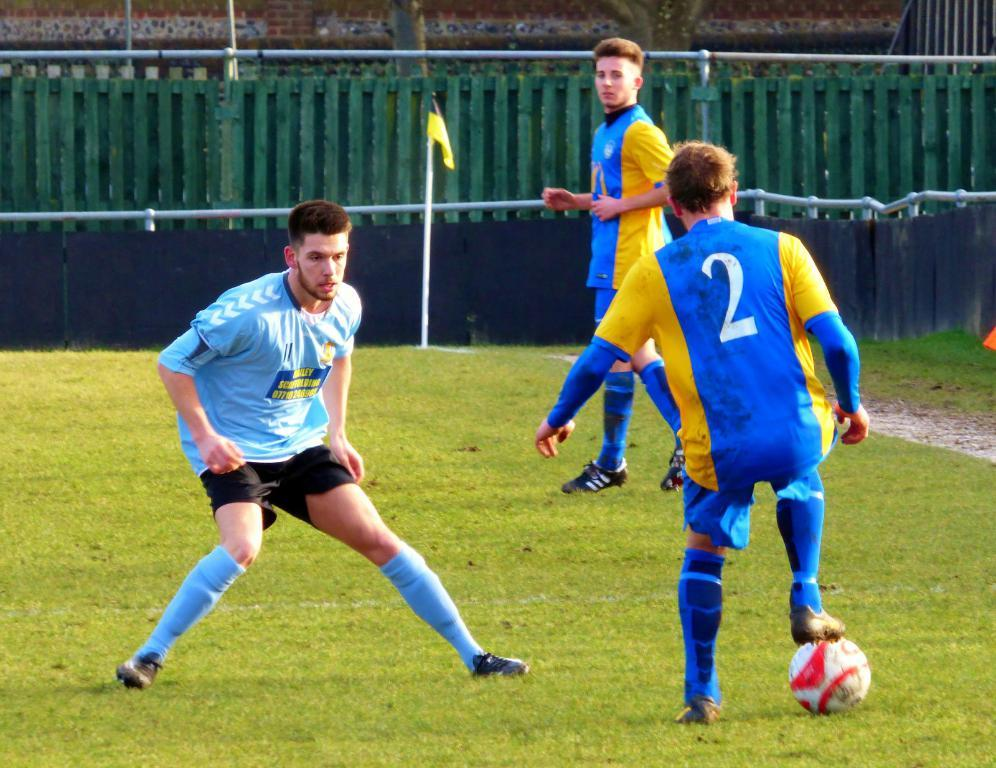<image>
Offer a succinct explanation of the picture presented. A scaffolding company is the sponsor on one of the player's jerseys. 